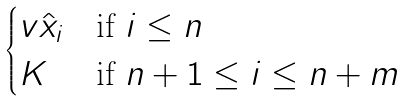<formula> <loc_0><loc_0><loc_500><loc_500>\begin{cases} v \hat { x } _ { i } & \text {if $i \leq n$} \\ K & \text {if $n+1 \leq i \leq n+m$} \\ \end{cases}</formula> 